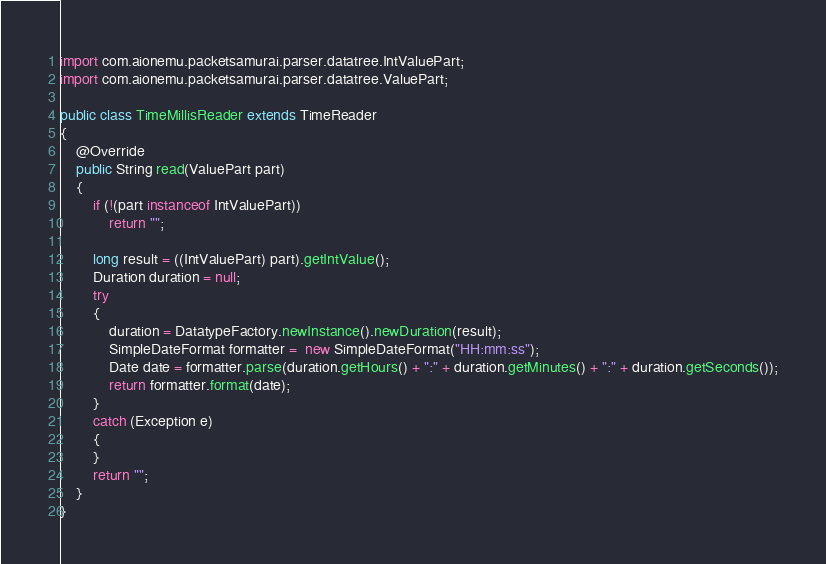<code> <loc_0><loc_0><loc_500><loc_500><_Java_>
import com.aionemu.packetsamurai.parser.datatree.IntValuePart;
import com.aionemu.packetsamurai.parser.datatree.ValuePart;

public class TimeMillisReader extends TimeReader 
{
    @Override
    public String read(ValuePart part)  
    {
        if (!(part instanceof IntValuePart))
            return "";

        long result = ((IntValuePart) part).getIntValue();
        Duration duration = null;
		try 
		{
			duration = DatatypeFactory.newInstance().newDuration(result);
			SimpleDateFormat formatter =  new SimpleDateFormat("HH:mm:ss");
			Date date = formatter.parse(duration.getHours() + ":" + duration.getMinutes() + ":" + duration.getSeconds());
			return formatter.format(date);
		} 
		catch (Exception e) 
		{
		}
		return "";
    }
}
</code> 